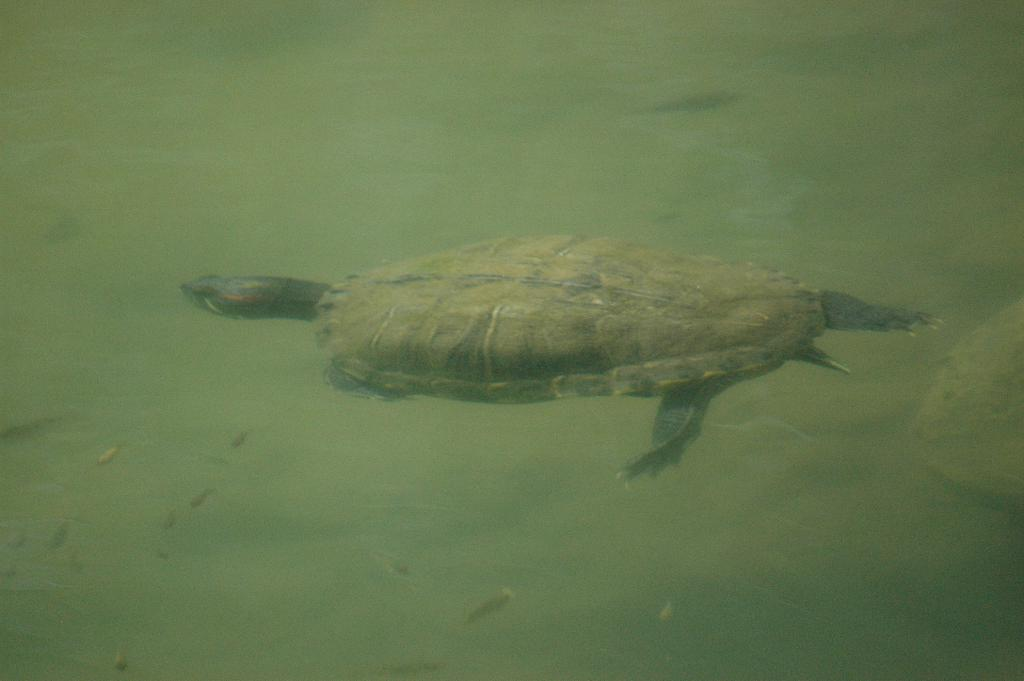What type of animal is in the image? There is a turtle in the image. What other creatures can be seen in the image? There are tiny fishes in the image. What is the color of the water in the image? The water appears green in color. Where are the cows located in the image? There are no cows present in the image. Is the turtle in a zoo or a bedroom in the image? The image does not provide any information about the location of the turtle, such as a zoo or a bedroom. 